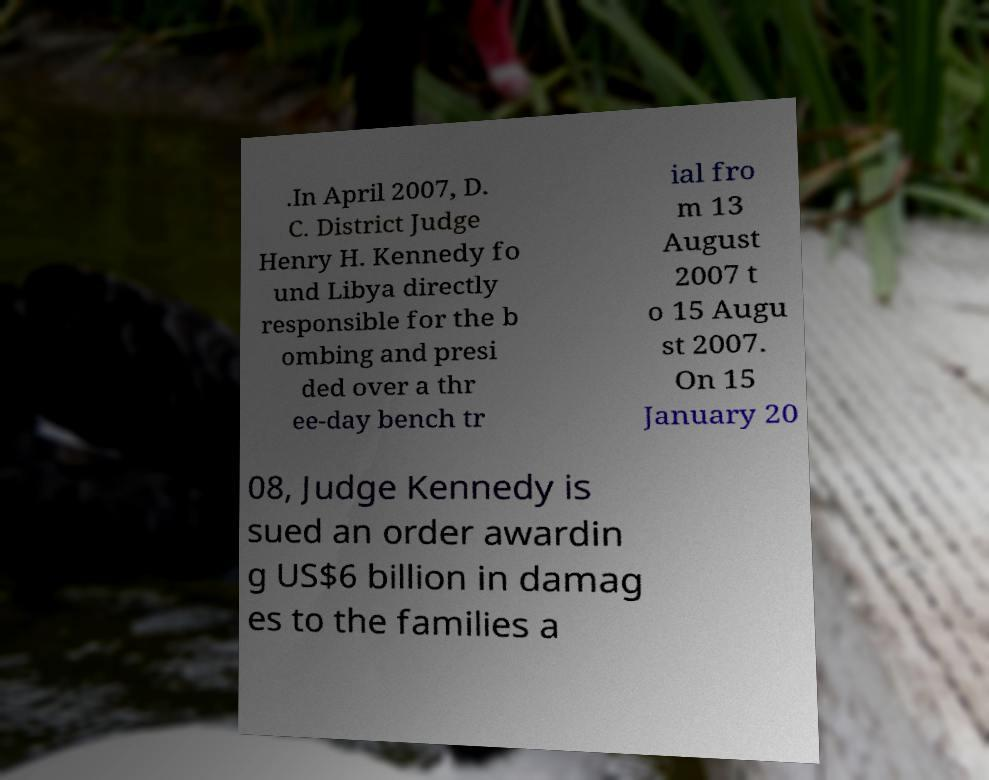For documentation purposes, I need the text within this image transcribed. Could you provide that? .In April 2007, D. C. District Judge Henry H. Kennedy fo und Libya directly responsible for the b ombing and presi ded over a thr ee-day bench tr ial fro m 13 August 2007 t o 15 Augu st 2007. On 15 January 20 08, Judge Kennedy is sued an order awardin g US$6 billion in damag es to the families a 